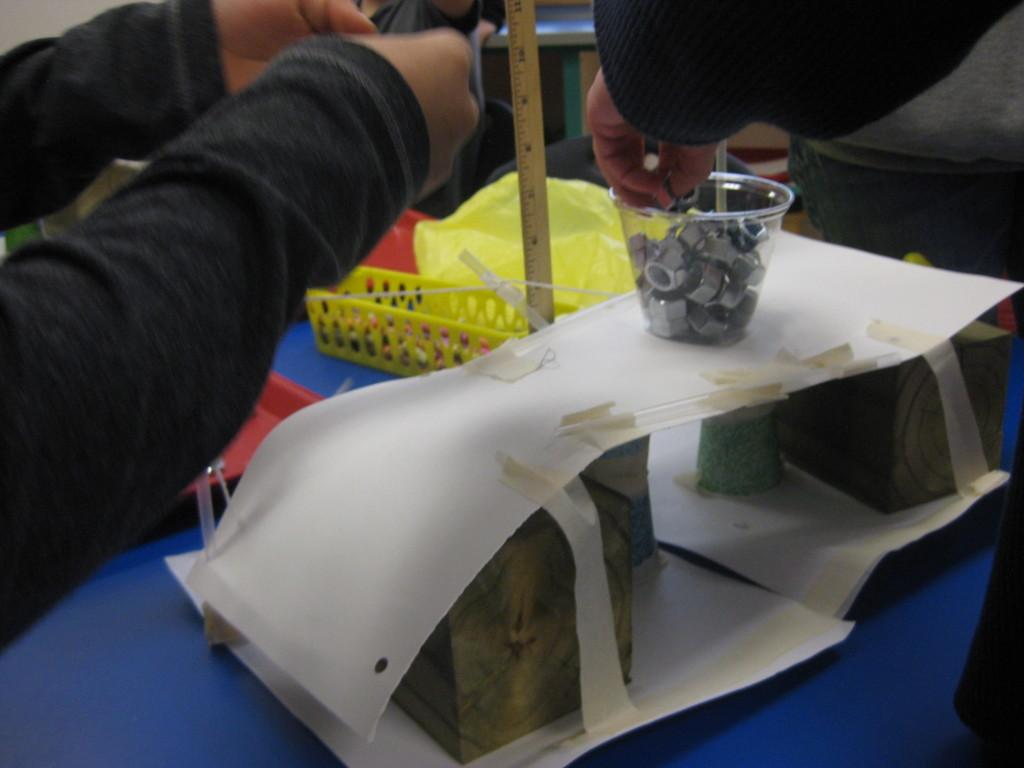What type of covers are visible in the image? The covers in the image are not specified, but they are present. What other objects can be seen in the image? There are papers, pipes, wooden pieces, and bolts visible in the image. How are these items arranged in the image? The items mentioned are in a glass and on a platform. Are there any people in the image? Yes, there are a few persons in the image. What type of dress is being worn by the structure in the image? There is no structure or dress present in the image. How many parcels are being delivered by the persons in the image? There is no mention of parcels or delivery in the image. 